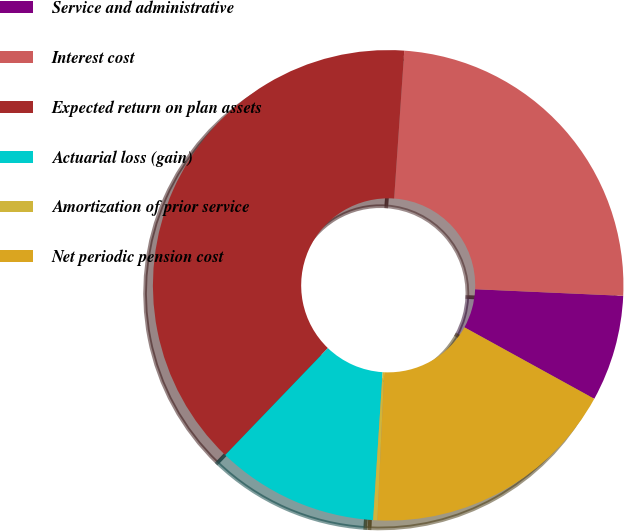<chart> <loc_0><loc_0><loc_500><loc_500><pie_chart><fcel>Service and administrative<fcel>Interest cost<fcel>Expected return on plan assets<fcel>Actuarial loss (gain)<fcel>Amortization of prior service<fcel>Net periodic pension cost<nl><fcel>7.3%<fcel>24.62%<fcel>38.91%<fcel>11.16%<fcel>0.29%<fcel>17.72%<nl></chart> 